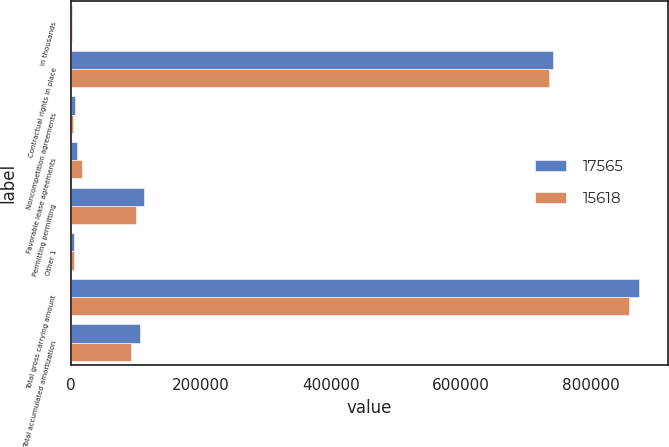<chart> <loc_0><loc_0><loc_500><loc_500><stacked_bar_chart><ecel><fcel>in thousands<fcel>Contractual rights in place<fcel>Noncompetition agreements<fcel>Favorable lease agreements<fcel>Permitting permitting<fcel>Other 1<fcel>Total gross carrying amount<fcel>Total accumulated amortization<nl><fcel>17565<fcel>2016<fcel>742085<fcel>6757<fcel>9479<fcel>112058<fcel>4171<fcel>874550<fcel>105498<nl><fcel>15618<fcel>2015<fcel>735935<fcel>2800<fcel>16677<fcel>99513<fcel>4092<fcel>859017<fcel>92438<nl></chart> 